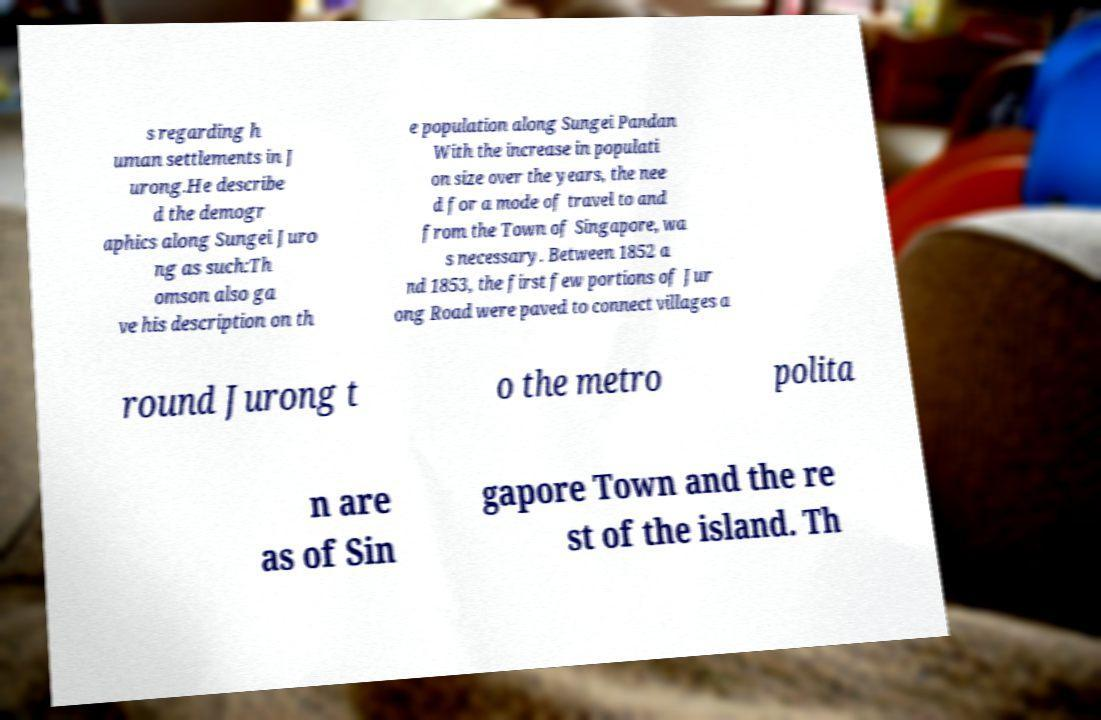Please identify and transcribe the text found in this image. s regarding h uman settlements in J urong.He describe d the demogr aphics along Sungei Juro ng as such:Th omson also ga ve his description on th e population along Sungei Pandan With the increase in populati on size over the years, the nee d for a mode of travel to and from the Town of Singapore, wa s necessary. Between 1852 a nd 1853, the first few portions of Jur ong Road were paved to connect villages a round Jurong t o the metro polita n are as of Sin gapore Town and the re st of the island. Th 